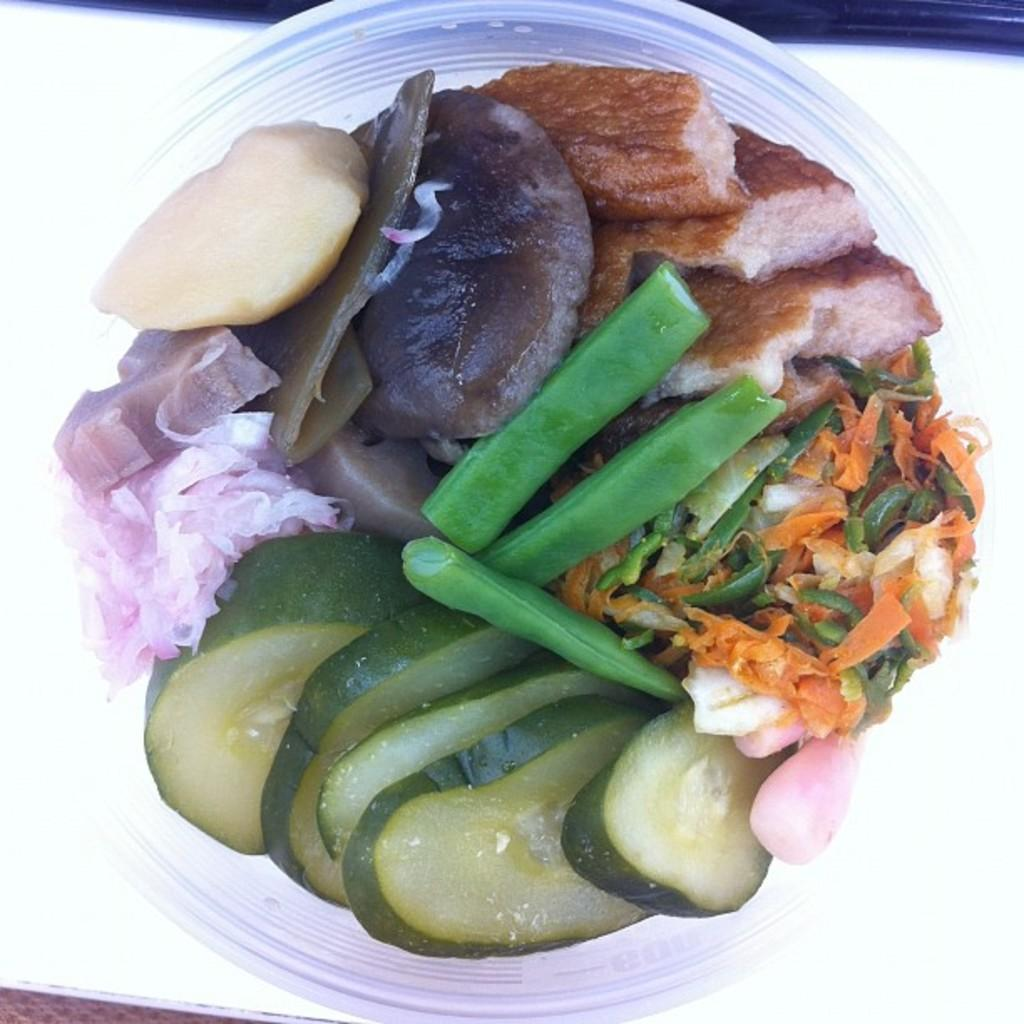What is in the bowl that is visible in the image? The bowl contains slices of onion, slices of carrot, other vegetables, and other food items. Can you describe the contents of the bowl in more detail? The bowl contains a variety of vegetables, including onion and carrot slices, as well as other food items. What design is featured on the war in the image? There is no war present in the image; it features a bowl with various food items. 